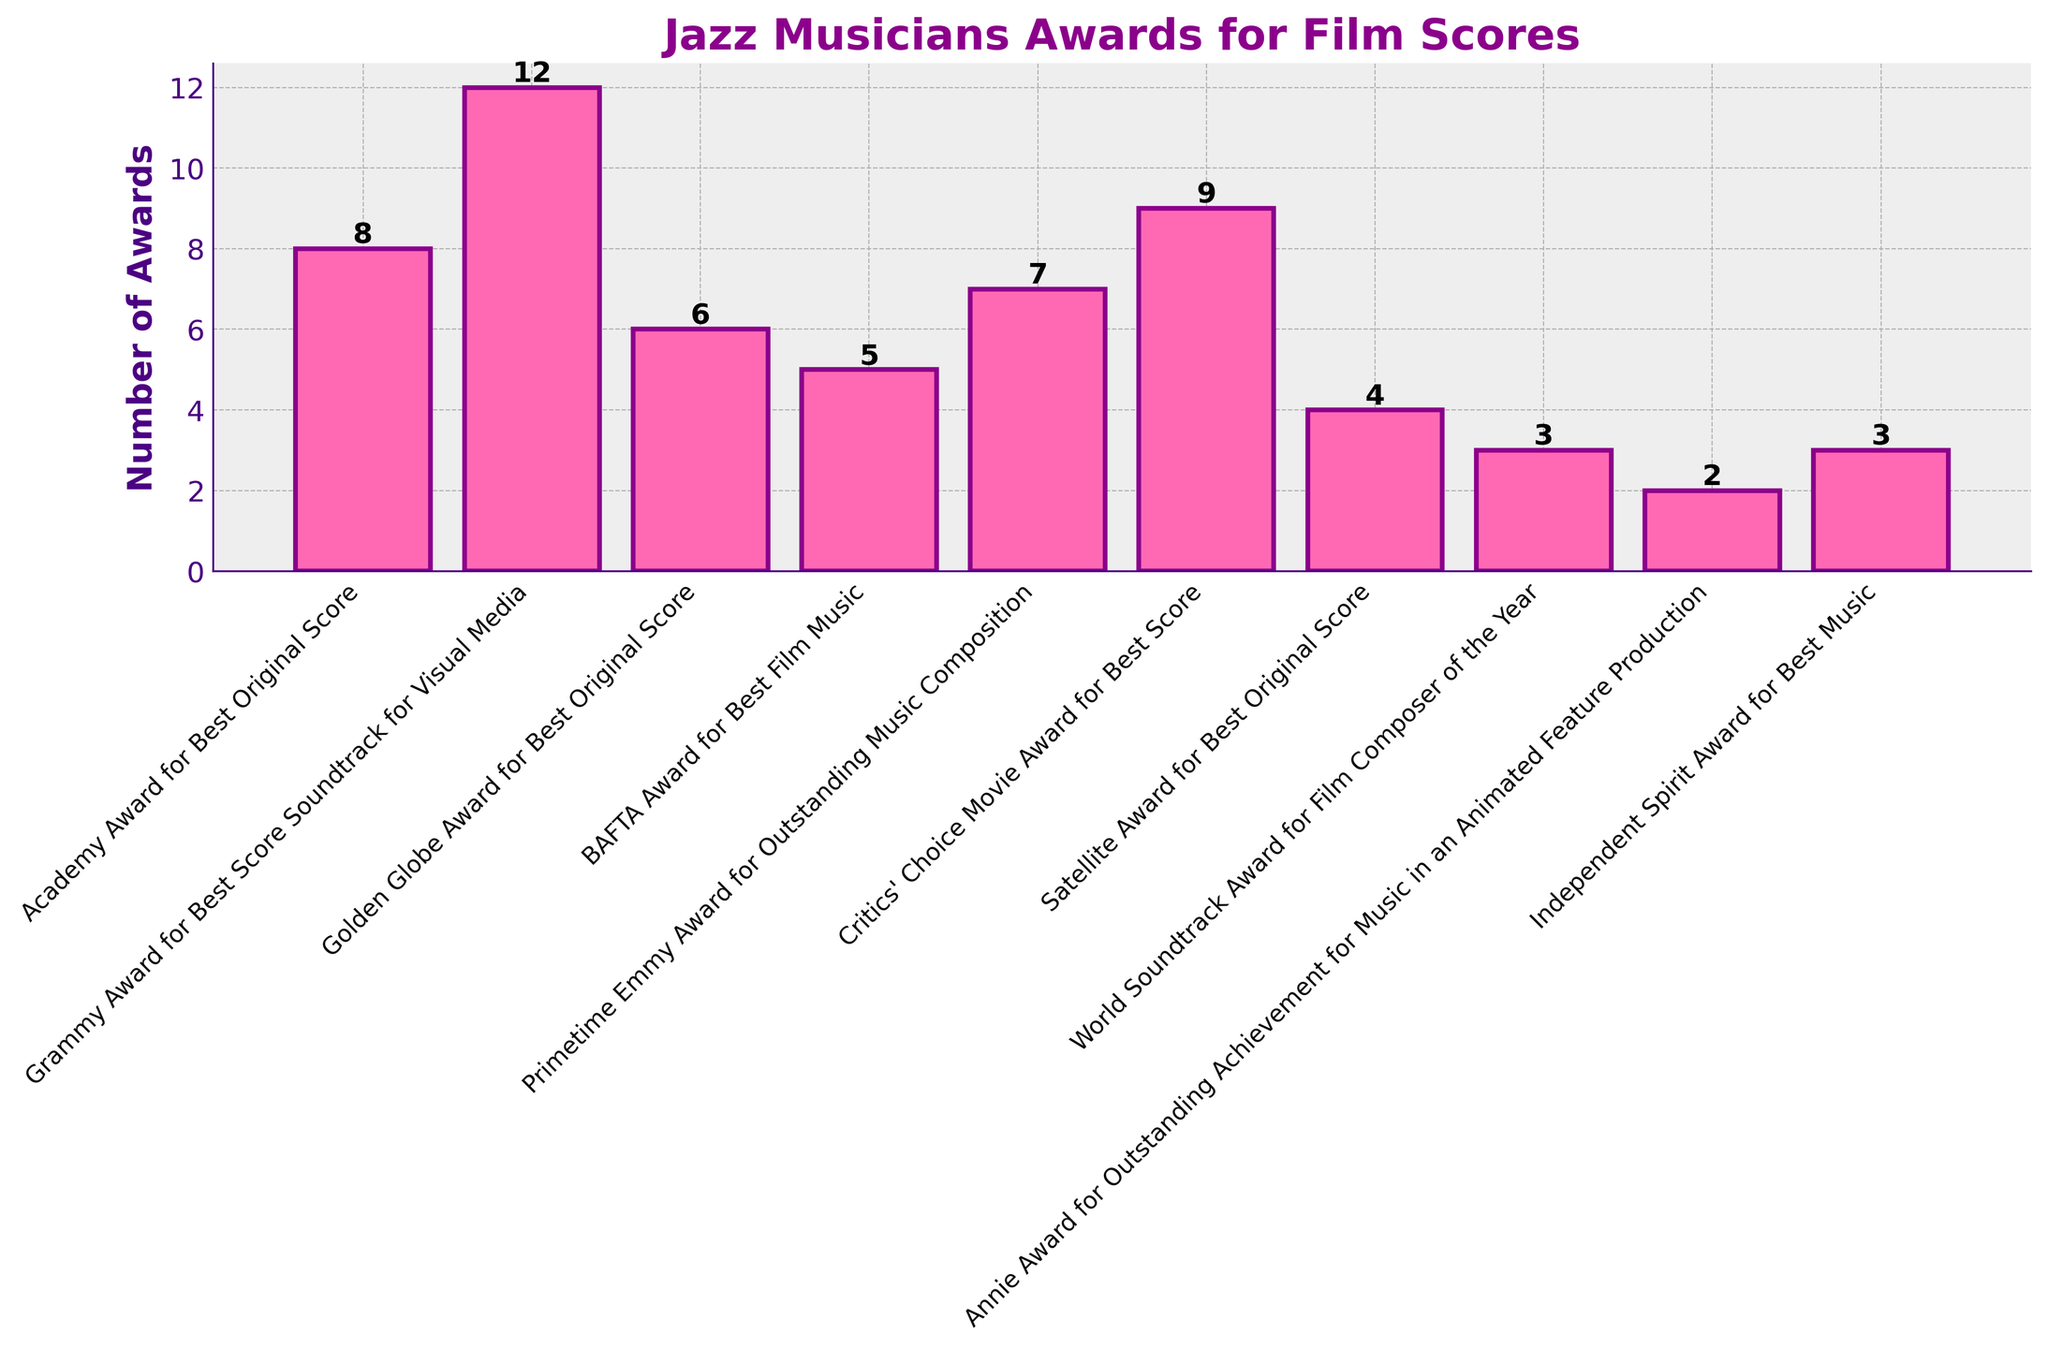Which award category has the highest number of awards? To determine the category with the highest number of awards, identify the tallest bar in the bar chart. The tallest bar corresponds to the "Grammy Award for Best Score Soundtrack for Visual Media" with 12 awards.
Answer: Grammy Award for Best Score Soundtrack for Visual Media What is the total number of awards won across all categories? Sum the values of all the bars. The total is 8 + 12 + 6 + 5 + 7 + 9 + 4 + 3 + 2 + 3 = 59.
Answer: 59 Which categories have an equal number of awards? Identify categories with bars of equal height. The "World Soundtrack Award for Film Composer of the Year" and "Independent Spirit Award for Best Music" each have 3 awards.
Answer: World Soundtrack Award for Film Composer of the Year, Independent Spirit Award for Best Music What is the ratio of the number of Grammy Awards to Academy Awards? Divide the number of Grammy Awards (12) by the number of Academy Awards (8). The ratio is 12/8 = 3/2.
Answer: 3:2 Which award category has the least number of awards, and how many awards are there? Identify the shortest bar. The shortest bar corresponds to "Annie Award for Outstanding Achievement for Music in an Animated Feature Production" with 2 awards.
Answer: Annie Award for Outstanding Achievement for Music in an Animated Feature Production, 2 How many more Critics' Choice Movie Awards are there compared to Satellite Awards? Subtract the number of Satellite Awards (4) from the number of Critics' Choice Movie Awards (9). The difference is 9 - 4 = 5.
Answer: 5 What is the average number of awards won across all categories? Calculate the total number of awards (59) and divide it by the number of categories (10). The average is 59/10 = 5.9.
Answer: 5.9 Among the top three categories with the most awards, what is the combined total? Identify the top three categories: Grammy Award for Best Score Soundtrack for Visual Media (12), Critics' Choice Movie Award for Best Score (9), and Academy Award for Best Original Score (8). Sum their values: 12 + 9 + 8 = 29.
Answer: 29 